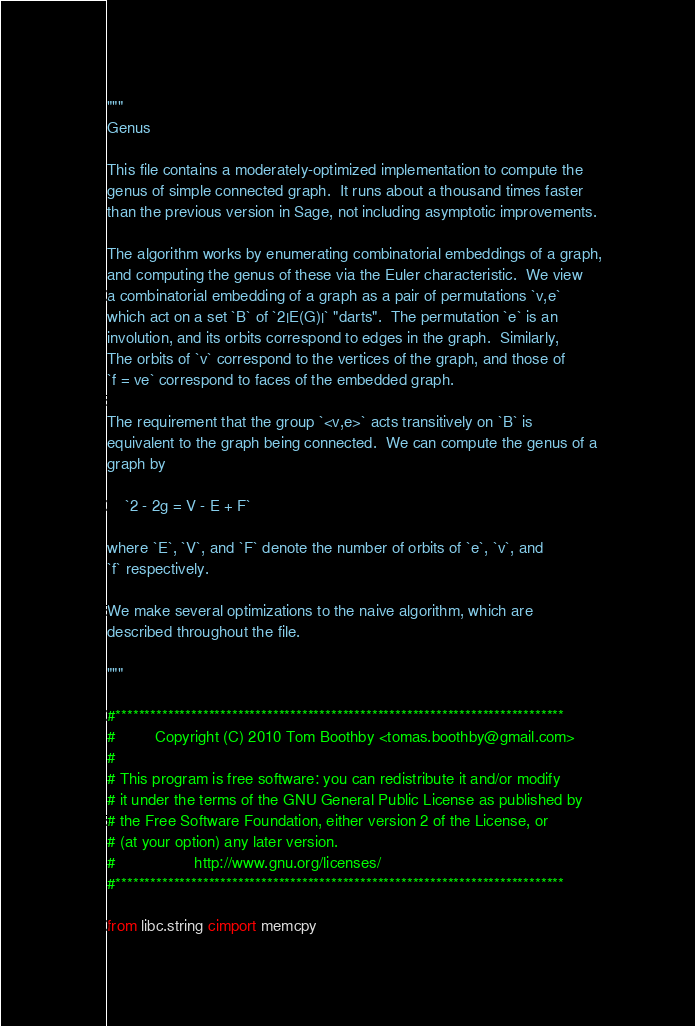Convert code to text. <code><loc_0><loc_0><loc_500><loc_500><_Cython_>"""
Genus

This file contains a moderately-optimized implementation to compute the
genus of simple connected graph.  It runs about a thousand times faster
than the previous version in Sage, not including asymptotic improvements.

The algorithm works by enumerating combinatorial embeddings of a graph,
and computing the genus of these via the Euler characteristic.  We view
a combinatorial embedding of a graph as a pair of permutations `v,e`
which act on a set `B` of `2|E(G)|` "darts".  The permutation `e` is an
involution, and its orbits correspond to edges in the graph.  Similarly,
The orbits of `v` correspond to the vertices of the graph, and those of
`f = ve` correspond to faces of the embedded graph.

The requirement that the group `<v,e>` acts transitively on `B` is
equivalent to the graph being connected.  We can compute the genus of a
graph by

    `2 - 2g = V - E + F`

where `E`, `V`, and `F` denote the number of orbits of `e`, `v`, and
`f` respectively.

We make several optimizations to the naive algorithm, which are
described throughout the file.

"""

#*****************************************************************************
#         Copyright (C) 2010 Tom Boothby <tomas.boothby@gmail.com>
#
# This program is free software: you can redistribute it and/or modify
# it under the terms of the GNU General Public License as published by
# the Free Software Foundation, either version 2 of the License, or
# (at your option) any later version.
#                  http://www.gnu.org/licenses/
#*****************************************************************************

from libc.string cimport memcpy</code> 